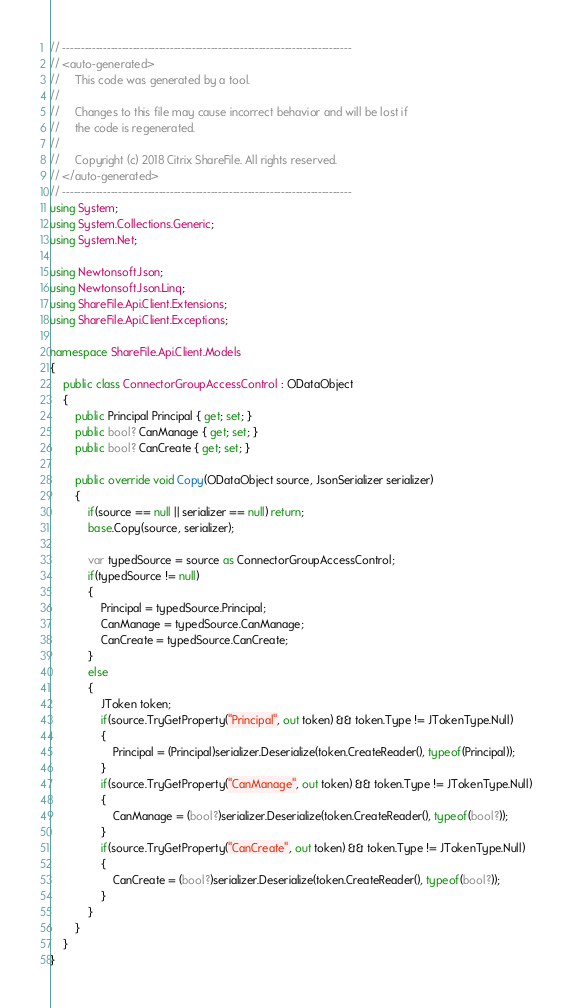Convert code to text. <code><loc_0><loc_0><loc_500><loc_500><_C#_>// ------------------------------------------------------------------------------
// <auto-generated>
//     This code was generated by a tool.
//  
//     Changes to this file may cause incorrect behavior and will be lost if
//     the code is regenerated.
//     
//	   Copyright (c) 2018 Citrix ShareFile. All rights reserved.
// </auto-generated>
// ------------------------------------------------------------------------------
using System;
using System.Collections.Generic;
using System.Net;

using Newtonsoft.Json;
using Newtonsoft.Json.Linq;
using ShareFile.Api.Client.Extensions;
using ShareFile.Api.Client.Exceptions;

namespace ShareFile.Api.Client.Models 
{
	public class ConnectorGroupAccessControl : ODataObject 
	{
		public Principal Principal { get; set; }
		public bool? CanManage { get; set; }
		public bool? CanCreate { get; set; }

		public override void Copy(ODataObject source, JsonSerializer serializer)
		{
			if(source == null || serializer == null) return;
			base.Copy(source, serializer);

			var typedSource = source as ConnectorGroupAccessControl;
			if(typedSource != null)
			{
				Principal = typedSource.Principal;
				CanManage = typedSource.CanManage;
				CanCreate = typedSource.CanCreate;
			}
			else
			{
				JToken token;
				if(source.TryGetProperty("Principal", out token) && token.Type != JTokenType.Null)
				{
					Principal = (Principal)serializer.Deserialize(token.CreateReader(), typeof(Principal));
				}
				if(source.TryGetProperty("CanManage", out token) && token.Type != JTokenType.Null)
				{
					CanManage = (bool?)serializer.Deserialize(token.CreateReader(), typeof(bool?));
				}
				if(source.TryGetProperty("CanCreate", out token) && token.Type != JTokenType.Null)
				{
					CanCreate = (bool?)serializer.Deserialize(token.CreateReader(), typeof(bool?));
				}
			}
		}
	}
}</code> 